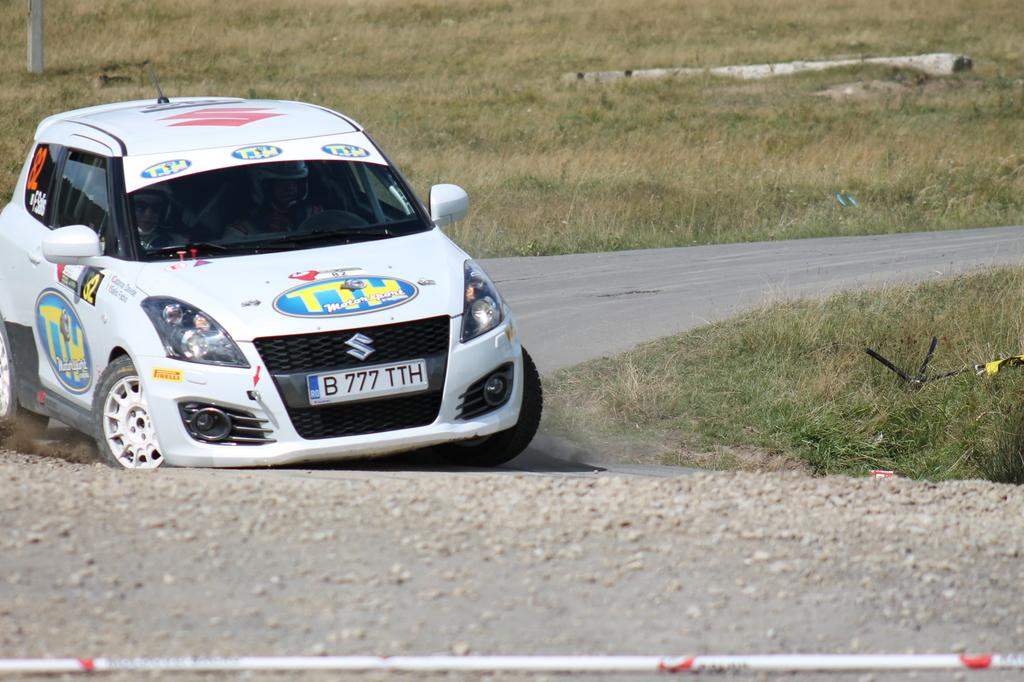What type of vehicle is in the image? There is a white car in the image. What is the car doing in the image? The car is moving on the road. What can be seen in the foreground of the image? There is grass visible in the image. How would you describe the background of the image? The background of the image is slightly blurred. Where is the nearest store to the car in the image? There is no store visible in the image, so it is impossible to determine the nearest store's location. 